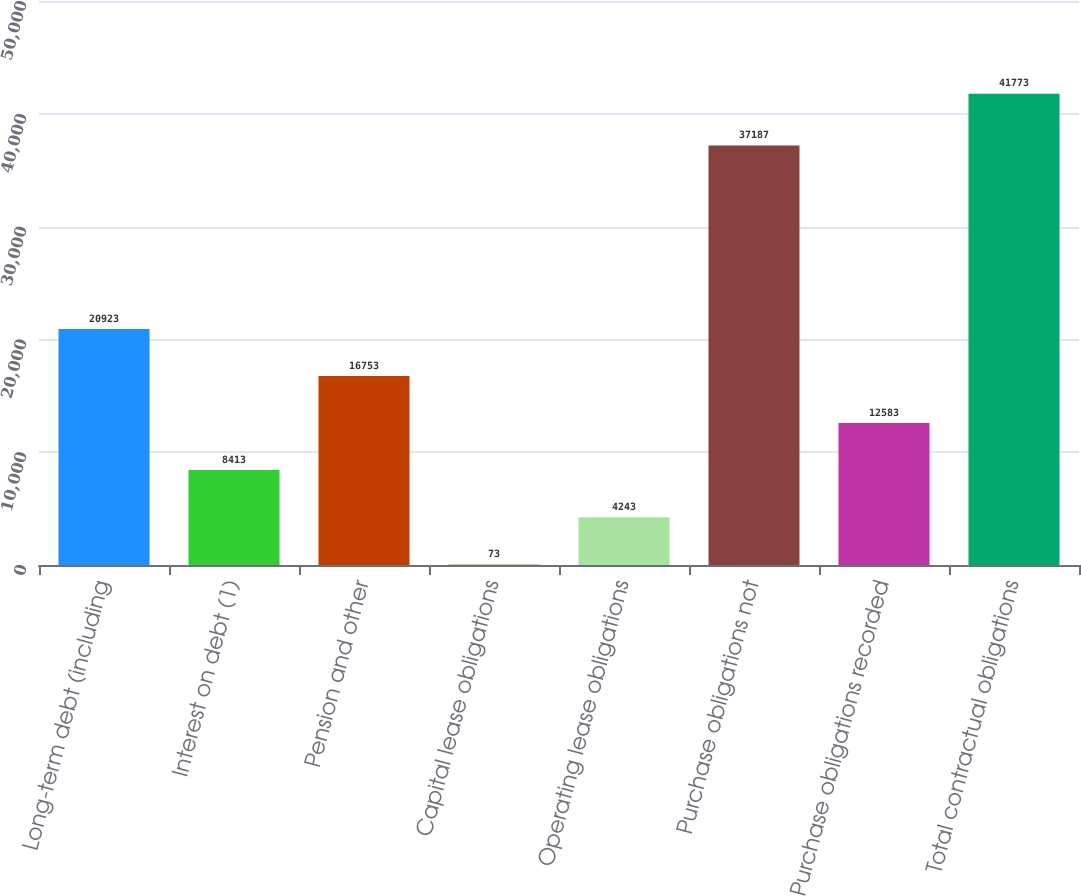Convert chart to OTSL. <chart><loc_0><loc_0><loc_500><loc_500><bar_chart><fcel>Long-term debt (including<fcel>Interest on debt (1)<fcel>Pension and other<fcel>Capital lease obligations<fcel>Operating lease obligations<fcel>Purchase obligations not<fcel>Purchase obligations recorded<fcel>Total contractual obligations<nl><fcel>20923<fcel>8413<fcel>16753<fcel>73<fcel>4243<fcel>37187<fcel>12583<fcel>41773<nl></chart> 